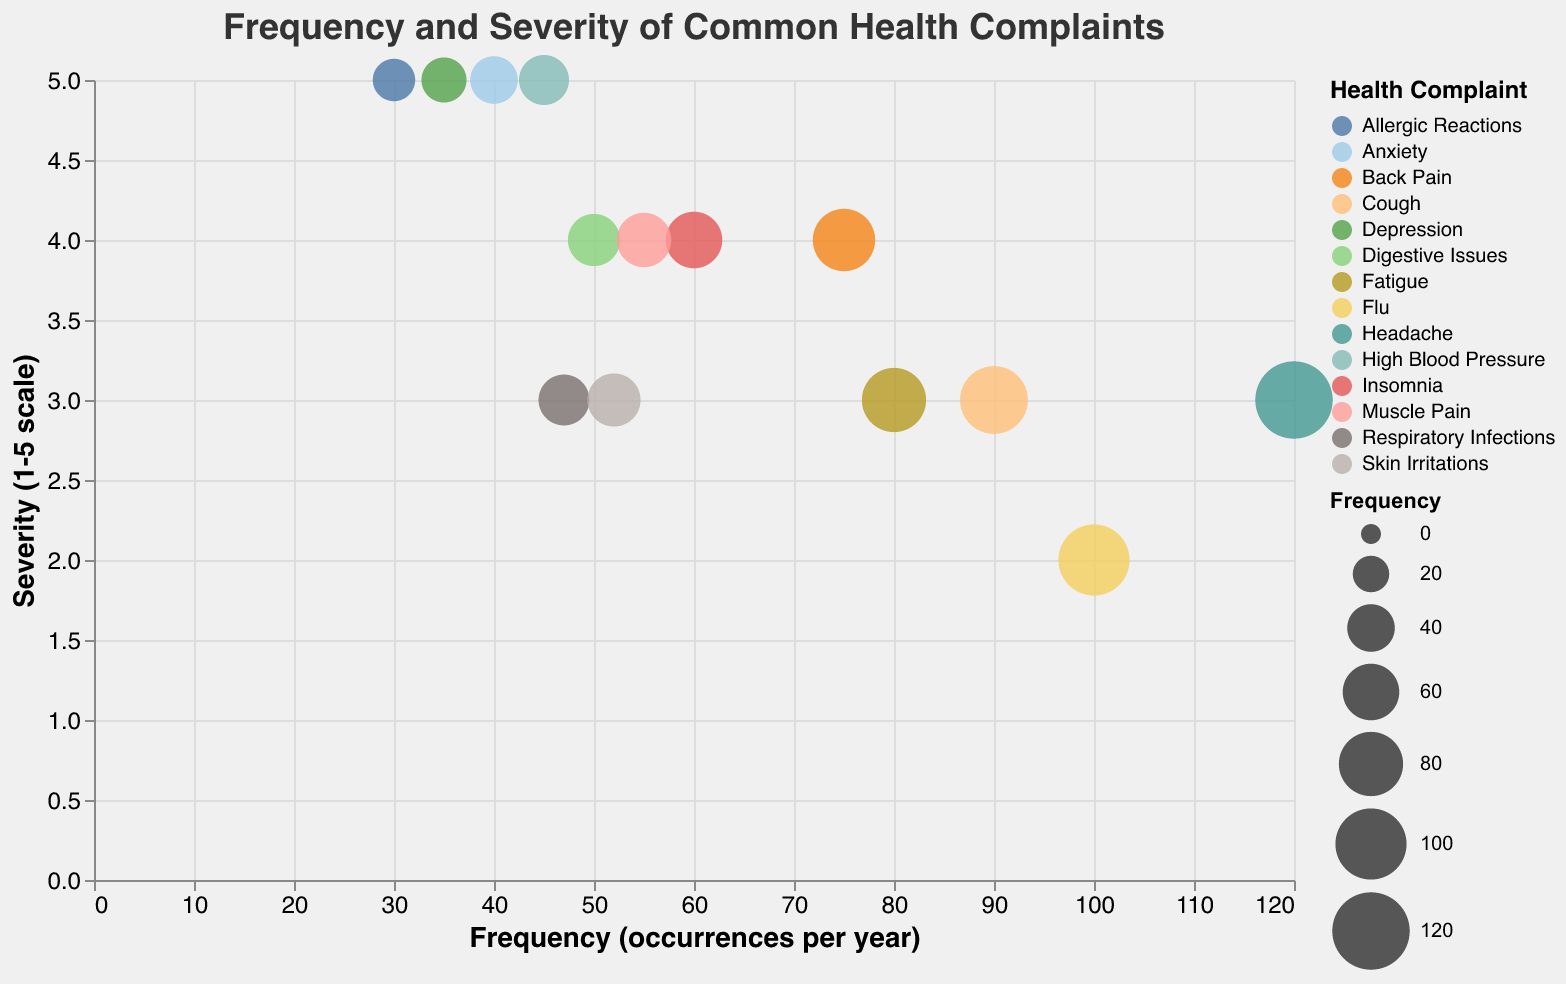What is the title of the figure? The title of a chart is usually located at the top and provides an overview of what the chart represents. In this case, it is "Frequency and Severity of Common Health Complaints".
Answer: Frequency and Severity of Common Health Complaints Which health complaint has the highest frequency? To find the health complaint with the highest frequency, look for the largest circle or the one furthest to the right on the x-axis. In this case, "Headache" has the highest frequency of 120.
Answer: Headache Which health complaint has the highest severity? To determine the highest severity, look for the circle that is placed at the highest point on the y-axis. "Allergic Reactions", "Anxiety", "High Blood Pressure", and "Depression" all have the highest severity value of 5.
Answer: Allergic Reactions, Anxiety, High Blood Pressure, and Depression How many health complaints have a severity of 4? Each circle’s position on the y-axis indicates its severity. Count all the circles that are aligned with the severity mark of 4. The health complaints are "Back Pain", "Digestive Issues", "Insomnia", and "Muscle Pain".
Answer: Four What is the frequency difference between "Headache" and "Flu"? Subtract the frequency of "Flu" (100) from "Headache" (120) to get the difference.
Answer: 20 Which health complaint has the highest frequency among those with a severity of 3? Among the complaints with a severity of 3, compare their frequencies. "Headache" has the highest frequency of 120 among the severity 3 complaints.
Answer: Headache Which health complaint with a severity of 5 occurs least frequently? Find the complaint with a severity of 5 that is placed furthest to the left on the x-axis. "Depression" has the lowest frequency of 35 among severity 5 complaints.
Answer: Depression Are there more complaints with a severity of 3 or 4? Count the number of complaints for each severity level. There are five complaints with a severity of 3 and four complaints with a severity of 4.
Answer: Severity 3 What’s the average frequency of complaints with a severity of 5? Add the frequencies of all complaints with a severity of 5: 30 (Allergic Reactions) + 40 (Anxiety) + 45 (High Blood Pressure) + 35 (Depression) = 150. Divide by the number of complaints (4): 150 / 4 = 37.5.
Answer: 37.5 